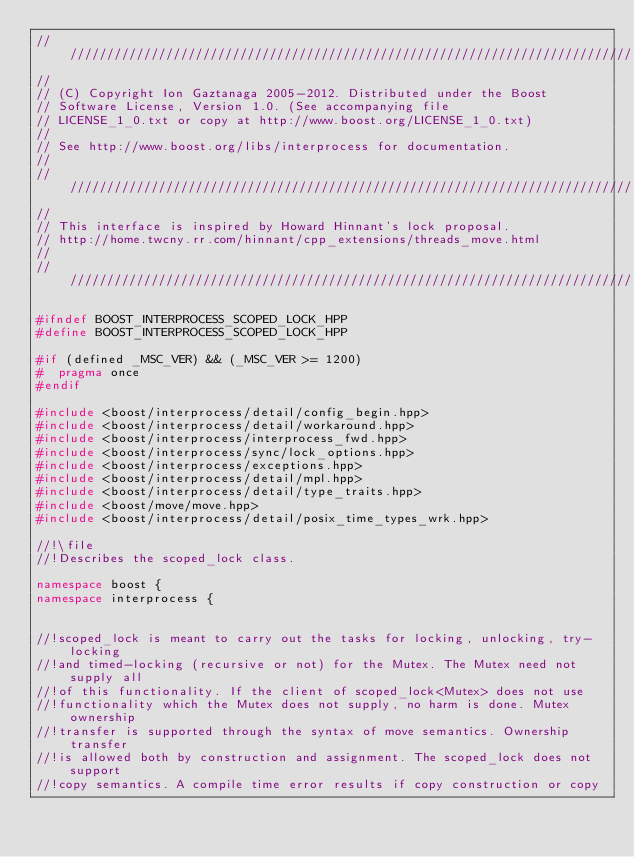Convert code to text. <code><loc_0><loc_0><loc_500><loc_500><_C++_>//////////////////////////////////////////////////////////////////////////////
//
// (C) Copyright Ion Gaztanaga 2005-2012. Distributed under the Boost
// Software License, Version 1.0. (See accompanying file
// LICENSE_1_0.txt or copy at http://www.boost.org/LICENSE_1_0.txt)
//
// See http://www.boost.org/libs/interprocess for documentation.
//
//////////////////////////////////////////////////////////////////////////////
//
// This interface is inspired by Howard Hinnant's lock proposal.
// http://home.twcny.rr.com/hinnant/cpp_extensions/threads_move.html
//
//////////////////////////////////////////////////////////////////////////////

#ifndef BOOST_INTERPROCESS_SCOPED_LOCK_HPP
#define BOOST_INTERPROCESS_SCOPED_LOCK_HPP

#if (defined _MSC_VER) && (_MSC_VER >= 1200)
#  pragma once
#endif

#include <boost/interprocess/detail/config_begin.hpp>
#include <boost/interprocess/detail/workaround.hpp>
#include <boost/interprocess/interprocess_fwd.hpp>
#include <boost/interprocess/sync/lock_options.hpp>
#include <boost/interprocess/exceptions.hpp>
#include <boost/interprocess/detail/mpl.hpp>
#include <boost/interprocess/detail/type_traits.hpp>
#include <boost/move/move.hpp>
#include <boost/interprocess/detail/posix_time_types_wrk.hpp>

//!\file
//!Describes the scoped_lock class.

namespace boost {
namespace interprocess {


//!scoped_lock is meant to carry out the tasks for locking, unlocking, try-locking
//!and timed-locking (recursive or not) for the Mutex. The Mutex need not supply all
//!of this functionality. If the client of scoped_lock<Mutex> does not use
//!functionality which the Mutex does not supply, no harm is done. Mutex ownership
//!transfer is supported through the syntax of move semantics. Ownership transfer
//!is allowed both by construction and assignment. The scoped_lock does not support
//!copy semantics. A compile time error results if copy construction or copy</code> 